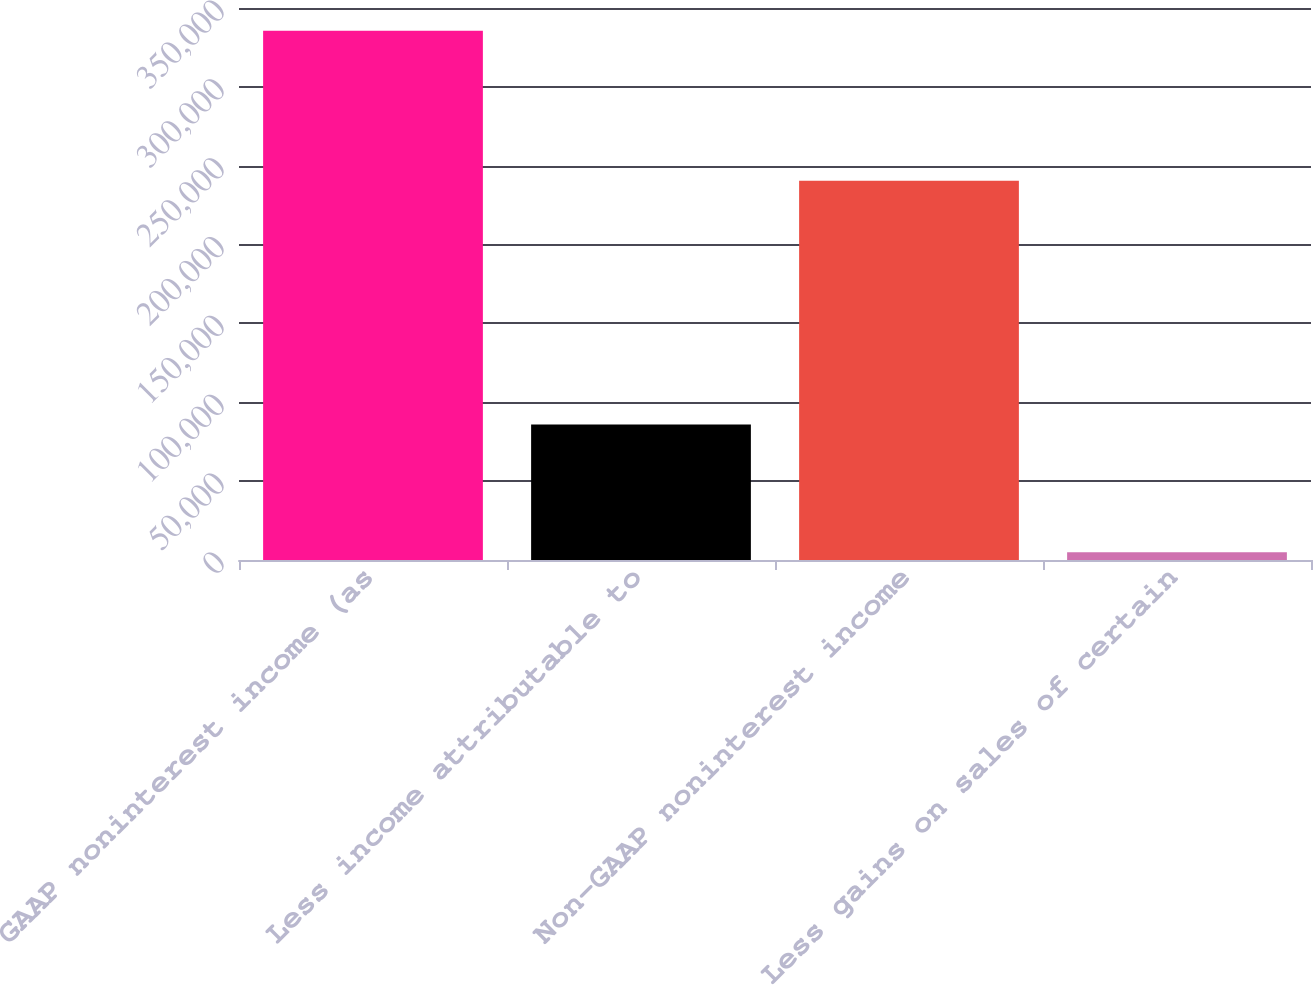<chart> <loc_0><loc_0><loc_500><loc_500><bar_chart><fcel>GAAP noninterest income (as<fcel>Less income attributable to<fcel>Non-GAAP noninterest income<fcel>Less gains on sales of certain<nl><fcel>335546<fcel>85940<fcel>240408<fcel>4955<nl></chart> 